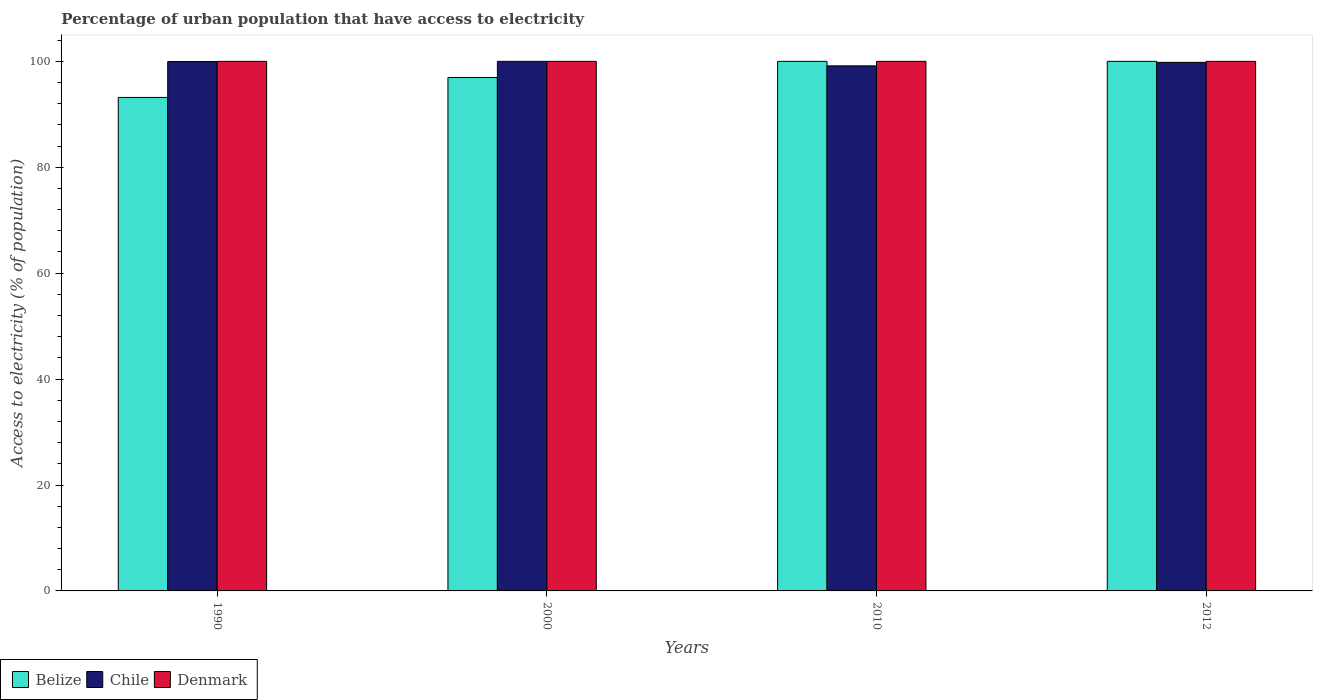How many different coloured bars are there?
Offer a terse response. 3. How many groups of bars are there?
Your response must be concise. 4. Are the number of bars on each tick of the X-axis equal?
Ensure brevity in your answer.  Yes. How many bars are there on the 3rd tick from the right?
Provide a succinct answer. 3. What is the label of the 1st group of bars from the left?
Your answer should be very brief. 1990. In how many cases, is the number of bars for a given year not equal to the number of legend labels?
Your answer should be compact. 0. What is the percentage of urban population that have access to electricity in Chile in 2010?
Ensure brevity in your answer.  99.15. Across all years, what is the maximum percentage of urban population that have access to electricity in Chile?
Make the answer very short. 100. Across all years, what is the minimum percentage of urban population that have access to electricity in Chile?
Your answer should be compact. 99.15. In which year was the percentage of urban population that have access to electricity in Chile maximum?
Offer a terse response. 2000. What is the total percentage of urban population that have access to electricity in Denmark in the graph?
Offer a very short reply. 400. What is the difference between the percentage of urban population that have access to electricity in Chile in 1990 and that in 2012?
Your answer should be very brief. 0.15. What is the difference between the percentage of urban population that have access to electricity in Belize in 2000 and the percentage of urban population that have access to electricity in Chile in 2012?
Provide a short and direct response. -2.87. What is the average percentage of urban population that have access to electricity in Belize per year?
Offer a very short reply. 97.53. In the year 2010, what is the difference between the percentage of urban population that have access to electricity in Chile and percentage of urban population that have access to electricity in Belize?
Make the answer very short. -0.85. What is the ratio of the percentage of urban population that have access to electricity in Denmark in 2000 to that in 2010?
Keep it short and to the point. 1. Is the percentage of urban population that have access to electricity in Denmark in 1990 less than that in 2010?
Your response must be concise. No. What is the difference between the highest and the lowest percentage of urban population that have access to electricity in Chile?
Keep it short and to the point. 0.85. What does the 1st bar from the left in 1990 represents?
Ensure brevity in your answer.  Belize. What does the 3rd bar from the right in 2010 represents?
Ensure brevity in your answer.  Belize. Is it the case that in every year, the sum of the percentage of urban population that have access to electricity in Belize and percentage of urban population that have access to electricity in Chile is greater than the percentage of urban population that have access to electricity in Denmark?
Your answer should be very brief. Yes. Are all the bars in the graph horizontal?
Give a very brief answer. No. How many years are there in the graph?
Your answer should be very brief. 4. What is the difference between two consecutive major ticks on the Y-axis?
Give a very brief answer. 20. Does the graph contain any zero values?
Your answer should be very brief. No. Does the graph contain grids?
Provide a short and direct response. No. Where does the legend appear in the graph?
Give a very brief answer. Bottom left. What is the title of the graph?
Offer a terse response. Percentage of urban population that have access to electricity. What is the label or title of the Y-axis?
Your response must be concise. Access to electricity (% of population). What is the Access to electricity (% of population) of Belize in 1990?
Keep it short and to the point. 93.19. What is the Access to electricity (% of population) of Chile in 1990?
Your answer should be compact. 99.96. What is the Access to electricity (% of population) in Denmark in 1990?
Give a very brief answer. 100. What is the Access to electricity (% of population) of Belize in 2000?
Ensure brevity in your answer.  96.95. What is the Access to electricity (% of population) in Chile in 2000?
Make the answer very short. 100. What is the Access to electricity (% of population) of Denmark in 2000?
Make the answer very short. 100. What is the Access to electricity (% of population) of Chile in 2010?
Ensure brevity in your answer.  99.15. What is the Access to electricity (% of population) of Belize in 2012?
Give a very brief answer. 100. What is the Access to electricity (% of population) in Chile in 2012?
Give a very brief answer. 99.81. What is the Access to electricity (% of population) of Denmark in 2012?
Make the answer very short. 100. Across all years, what is the maximum Access to electricity (% of population) in Belize?
Keep it short and to the point. 100. Across all years, what is the maximum Access to electricity (% of population) in Chile?
Provide a succinct answer. 100. Across all years, what is the minimum Access to electricity (% of population) of Belize?
Keep it short and to the point. 93.19. Across all years, what is the minimum Access to electricity (% of population) of Chile?
Offer a very short reply. 99.15. What is the total Access to electricity (% of population) of Belize in the graph?
Your response must be concise. 390.13. What is the total Access to electricity (% of population) of Chile in the graph?
Offer a very short reply. 398.93. What is the difference between the Access to electricity (% of population) of Belize in 1990 and that in 2000?
Offer a terse response. -3.76. What is the difference between the Access to electricity (% of population) of Chile in 1990 and that in 2000?
Your response must be concise. -0.04. What is the difference between the Access to electricity (% of population) in Belize in 1990 and that in 2010?
Your answer should be compact. -6.81. What is the difference between the Access to electricity (% of population) of Chile in 1990 and that in 2010?
Keep it short and to the point. 0.81. What is the difference between the Access to electricity (% of population) in Belize in 1990 and that in 2012?
Offer a terse response. -6.81. What is the difference between the Access to electricity (% of population) in Chile in 1990 and that in 2012?
Provide a succinct answer. 0.15. What is the difference between the Access to electricity (% of population) in Belize in 2000 and that in 2010?
Offer a very short reply. -3.05. What is the difference between the Access to electricity (% of population) in Chile in 2000 and that in 2010?
Provide a succinct answer. 0.85. What is the difference between the Access to electricity (% of population) in Belize in 2000 and that in 2012?
Provide a short and direct response. -3.05. What is the difference between the Access to electricity (% of population) in Chile in 2000 and that in 2012?
Ensure brevity in your answer.  0.19. What is the difference between the Access to electricity (% of population) in Denmark in 2000 and that in 2012?
Offer a terse response. 0. What is the difference between the Access to electricity (% of population) of Belize in 2010 and that in 2012?
Ensure brevity in your answer.  0. What is the difference between the Access to electricity (% of population) of Chile in 2010 and that in 2012?
Make the answer very short. -0.67. What is the difference between the Access to electricity (% of population) of Denmark in 2010 and that in 2012?
Your answer should be compact. 0. What is the difference between the Access to electricity (% of population) in Belize in 1990 and the Access to electricity (% of population) in Chile in 2000?
Provide a succinct answer. -6.81. What is the difference between the Access to electricity (% of population) of Belize in 1990 and the Access to electricity (% of population) of Denmark in 2000?
Keep it short and to the point. -6.81. What is the difference between the Access to electricity (% of population) of Chile in 1990 and the Access to electricity (% of population) of Denmark in 2000?
Offer a terse response. -0.04. What is the difference between the Access to electricity (% of population) in Belize in 1990 and the Access to electricity (% of population) in Chile in 2010?
Provide a succinct answer. -5.96. What is the difference between the Access to electricity (% of population) in Belize in 1990 and the Access to electricity (% of population) in Denmark in 2010?
Ensure brevity in your answer.  -6.81. What is the difference between the Access to electricity (% of population) in Chile in 1990 and the Access to electricity (% of population) in Denmark in 2010?
Your response must be concise. -0.04. What is the difference between the Access to electricity (% of population) of Belize in 1990 and the Access to electricity (% of population) of Chile in 2012?
Provide a succinct answer. -6.63. What is the difference between the Access to electricity (% of population) in Belize in 1990 and the Access to electricity (% of population) in Denmark in 2012?
Provide a succinct answer. -6.81. What is the difference between the Access to electricity (% of population) in Chile in 1990 and the Access to electricity (% of population) in Denmark in 2012?
Offer a very short reply. -0.04. What is the difference between the Access to electricity (% of population) in Belize in 2000 and the Access to electricity (% of population) in Chile in 2010?
Your answer should be very brief. -2.2. What is the difference between the Access to electricity (% of population) in Belize in 2000 and the Access to electricity (% of population) in Denmark in 2010?
Provide a succinct answer. -3.05. What is the difference between the Access to electricity (% of population) in Chile in 2000 and the Access to electricity (% of population) in Denmark in 2010?
Offer a terse response. 0. What is the difference between the Access to electricity (% of population) in Belize in 2000 and the Access to electricity (% of population) in Chile in 2012?
Ensure brevity in your answer.  -2.87. What is the difference between the Access to electricity (% of population) of Belize in 2000 and the Access to electricity (% of population) of Denmark in 2012?
Your answer should be very brief. -3.05. What is the difference between the Access to electricity (% of population) of Belize in 2010 and the Access to electricity (% of population) of Chile in 2012?
Keep it short and to the point. 0.19. What is the difference between the Access to electricity (% of population) in Chile in 2010 and the Access to electricity (% of population) in Denmark in 2012?
Make the answer very short. -0.85. What is the average Access to electricity (% of population) in Belize per year?
Make the answer very short. 97.53. What is the average Access to electricity (% of population) in Chile per year?
Your answer should be compact. 99.73. What is the average Access to electricity (% of population) in Denmark per year?
Make the answer very short. 100. In the year 1990, what is the difference between the Access to electricity (% of population) in Belize and Access to electricity (% of population) in Chile?
Offer a terse response. -6.78. In the year 1990, what is the difference between the Access to electricity (% of population) of Belize and Access to electricity (% of population) of Denmark?
Your answer should be compact. -6.81. In the year 1990, what is the difference between the Access to electricity (% of population) in Chile and Access to electricity (% of population) in Denmark?
Your answer should be compact. -0.04. In the year 2000, what is the difference between the Access to electricity (% of population) in Belize and Access to electricity (% of population) in Chile?
Make the answer very short. -3.05. In the year 2000, what is the difference between the Access to electricity (% of population) in Belize and Access to electricity (% of population) in Denmark?
Provide a succinct answer. -3.05. In the year 2000, what is the difference between the Access to electricity (% of population) in Chile and Access to electricity (% of population) in Denmark?
Ensure brevity in your answer.  0. In the year 2010, what is the difference between the Access to electricity (% of population) of Belize and Access to electricity (% of population) of Chile?
Keep it short and to the point. 0.85. In the year 2010, what is the difference between the Access to electricity (% of population) in Belize and Access to electricity (% of population) in Denmark?
Keep it short and to the point. 0. In the year 2010, what is the difference between the Access to electricity (% of population) of Chile and Access to electricity (% of population) of Denmark?
Provide a short and direct response. -0.85. In the year 2012, what is the difference between the Access to electricity (% of population) of Belize and Access to electricity (% of population) of Chile?
Give a very brief answer. 0.19. In the year 2012, what is the difference between the Access to electricity (% of population) of Chile and Access to electricity (% of population) of Denmark?
Your response must be concise. -0.19. What is the ratio of the Access to electricity (% of population) of Belize in 1990 to that in 2000?
Your response must be concise. 0.96. What is the ratio of the Access to electricity (% of population) in Denmark in 1990 to that in 2000?
Ensure brevity in your answer.  1. What is the ratio of the Access to electricity (% of population) of Belize in 1990 to that in 2010?
Ensure brevity in your answer.  0.93. What is the ratio of the Access to electricity (% of population) in Chile in 1990 to that in 2010?
Give a very brief answer. 1.01. What is the ratio of the Access to electricity (% of population) of Belize in 1990 to that in 2012?
Offer a very short reply. 0.93. What is the ratio of the Access to electricity (% of population) of Chile in 1990 to that in 2012?
Make the answer very short. 1. What is the ratio of the Access to electricity (% of population) of Denmark in 1990 to that in 2012?
Your answer should be compact. 1. What is the ratio of the Access to electricity (% of population) of Belize in 2000 to that in 2010?
Your answer should be very brief. 0.97. What is the ratio of the Access to electricity (% of population) of Chile in 2000 to that in 2010?
Offer a very short reply. 1.01. What is the ratio of the Access to electricity (% of population) in Denmark in 2000 to that in 2010?
Provide a succinct answer. 1. What is the ratio of the Access to electricity (% of population) of Belize in 2000 to that in 2012?
Offer a terse response. 0.97. What is the ratio of the Access to electricity (% of population) of Chile in 2000 to that in 2012?
Keep it short and to the point. 1. What is the ratio of the Access to electricity (% of population) in Denmark in 2000 to that in 2012?
Your response must be concise. 1. What is the ratio of the Access to electricity (% of population) of Belize in 2010 to that in 2012?
Your answer should be compact. 1. What is the ratio of the Access to electricity (% of population) in Chile in 2010 to that in 2012?
Keep it short and to the point. 0.99. What is the ratio of the Access to electricity (% of population) of Denmark in 2010 to that in 2012?
Make the answer very short. 1. What is the difference between the highest and the second highest Access to electricity (% of population) in Belize?
Offer a very short reply. 0. What is the difference between the highest and the second highest Access to electricity (% of population) of Chile?
Your response must be concise. 0.04. What is the difference between the highest and the lowest Access to electricity (% of population) in Belize?
Provide a short and direct response. 6.81. What is the difference between the highest and the lowest Access to electricity (% of population) of Chile?
Your answer should be very brief. 0.85. 